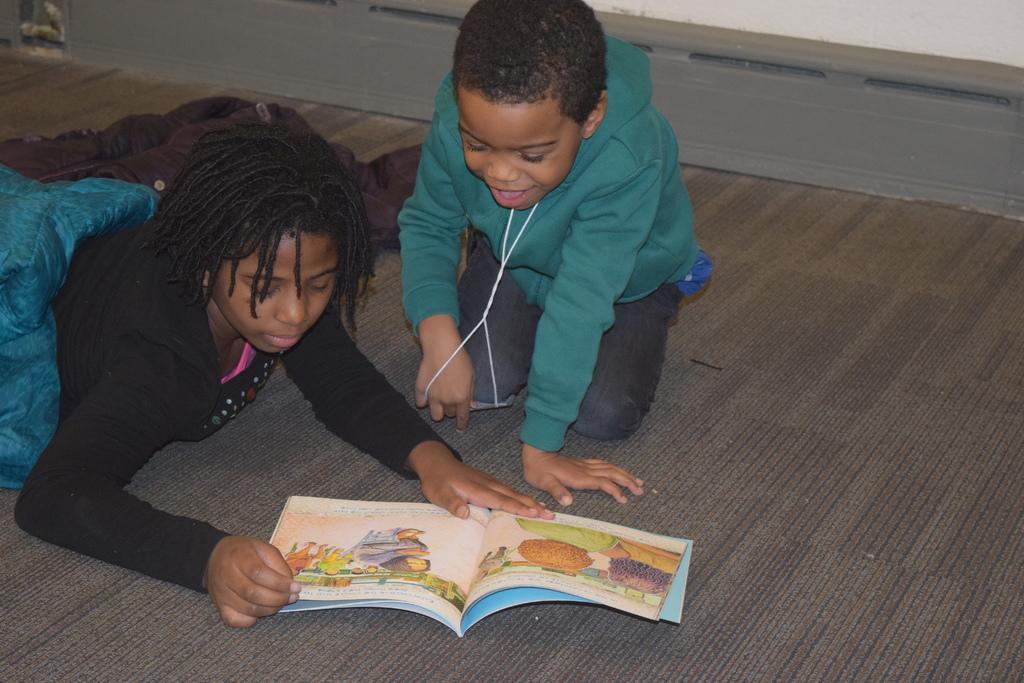Could you give a brief overview of what you see in this image? 2 people are present on the floor. They are reading a book. 